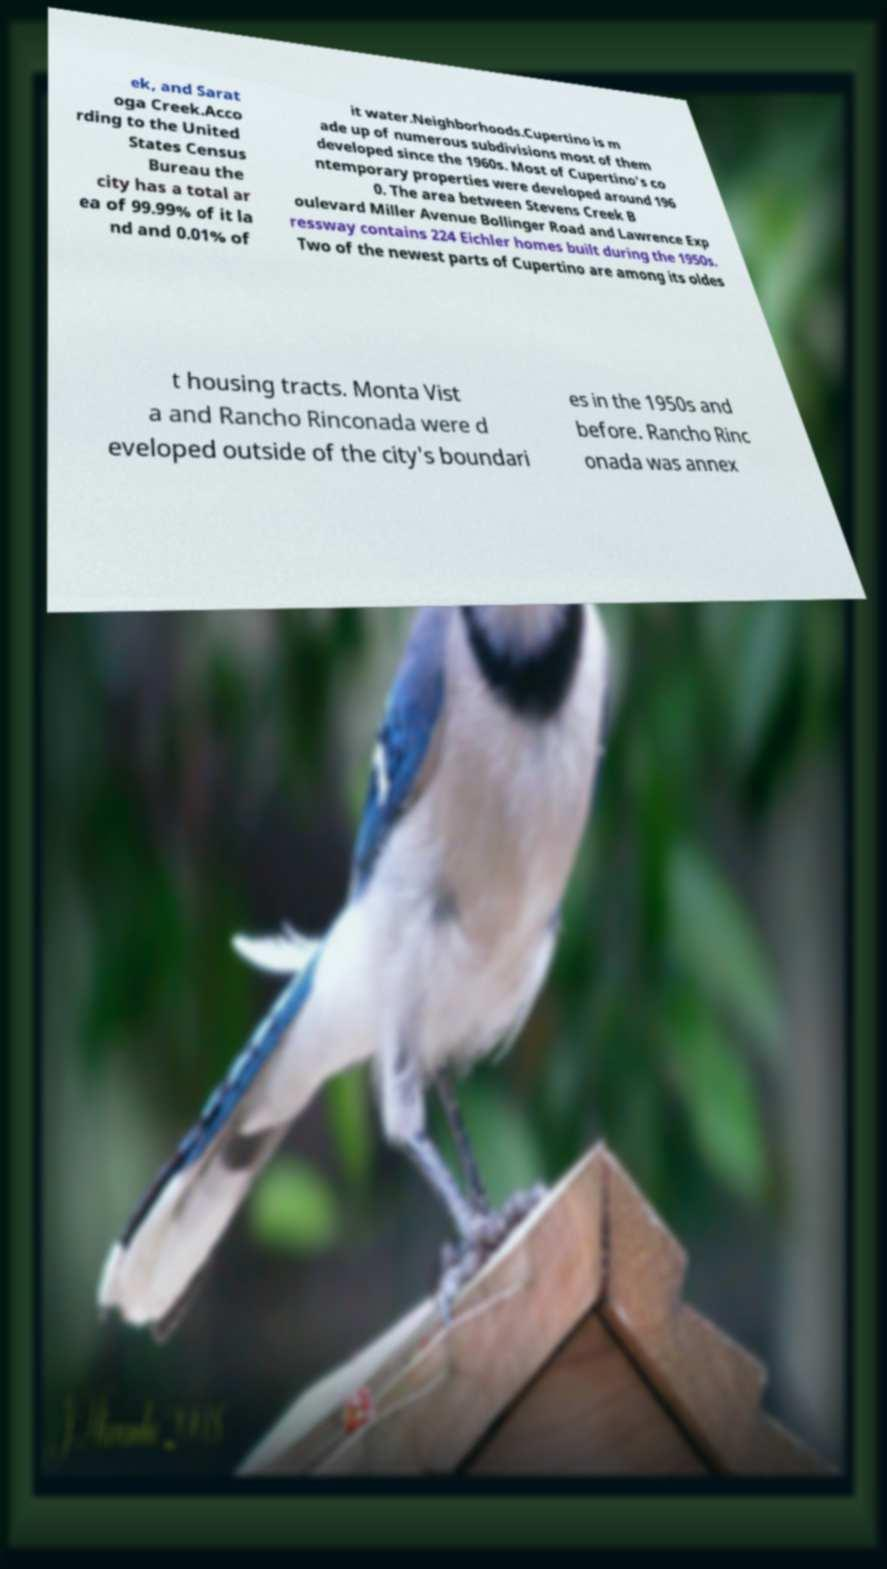I need the written content from this picture converted into text. Can you do that? ek, and Sarat oga Creek.Acco rding to the United States Census Bureau the city has a total ar ea of 99.99% of it la nd and 0.01% of it water.Neighborhoods.Cupertino is m ade up of numerous subdivisions most of them developed since the 1960s. Most of Cupertino's co ntemporary properties were developed around 196 0. The area between Stevens Creek B oulevard Miller Avenue Bollinger Road and Lawrence Exp ressway contains 224 Eichler homes built during the 1950s. Two of the newest parts of Cupertino are among its oldes t housing tracts. Monta Vist a and Rancho Rinconada were d eveloped outside of the city's boundari es in the 1950s and before. Rancho Rinc onada was annex 